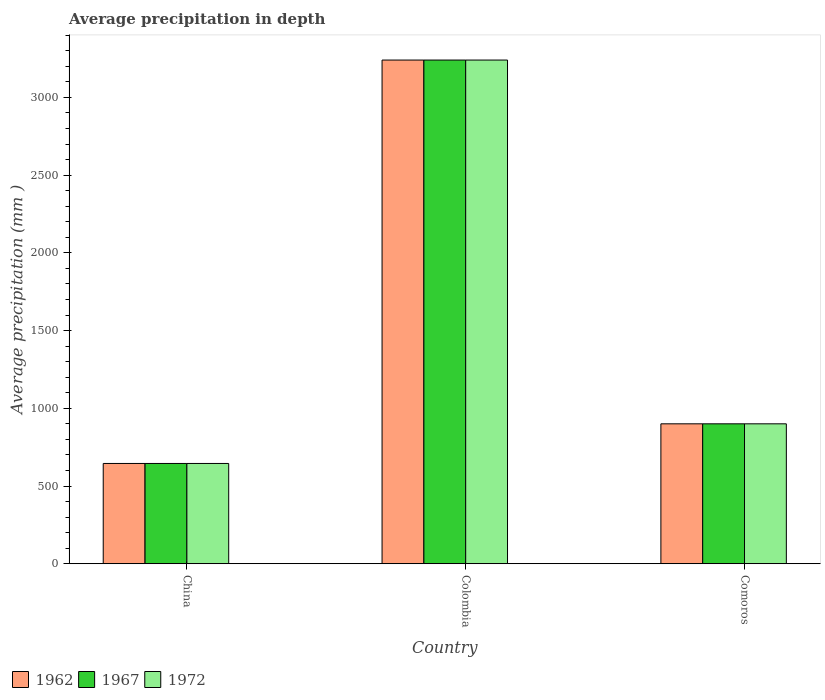How many different coloured bars are there?
Keep it short and to the point. 3. Are the number of bars per tick equal to the number of legend labels?
Your response must be concise. Yes. How many bars are there on the 1st tick from the left?
Provide a succinct answer. 3. What is the label of the 2nd group of bars from the left?
Offer a very short reply. Colombia. In how many cases, is the number of bars for a given country not equal to the number of legend labels?
Keep it short and to the point. 0. What is the average precipitation in 1972 in Comoros?
Offer a very short reply. 900. Across all countries, what is the maximum average precipitation in 1972?
Provide a short and direct response. 3240. Across all countries, what is the minimum average precipitation in 1972?
Keep it short and to the point. 645. In which country was the average precipitation in 1972 maximum?
Keep it short and to the point. Colombia. What is the total average precipitation in 1962 in the graph?
Keep it short and to the point. 4785. What is the difference between the average precipitation in 1962 in Colombia and that in Comoros?
Offer a terse response. 2340. What is the difference between the average precipitation in 1967 in Colombia and the average precipitation in 1962 in Comoros?
Provide a succinct answer. 2340. What is the average average precipitation in 1972 per country?
Give a very brief answer. 1595. In how many countries, is the average precipitation in 1972 greater than 600 mm?
Your answer should be compact. 3. What is the ratio of the average precipitation in 1972 in Colombia to that in Comoros?
Provide a succinct answer. 3.6. Is the average precipitation in 1972 in Colombia less than that in Comoros?
Your answer should be very brief. No. Is the difference between the average precipitation in 1972 in China and Comoros greater than the difference between the average precipitation in 1967 in China and Comoros?
Make the answer very short. No. What is the difference between the highest and the second highest average precipitation in 1972?
Keep it short and to the point. 2340. What is the difference between the highest and the lowest average precipitation in 1972?
Give a very brief answer. 2595. In how many countries, is the average precipitation in 1967 greater than the average average precipitation in 1967 taken over all countries?
Keep it short and to the point. 1. Is it the case that in every country, the sum of the average precipitation in 1967 and average precipitation in 1972 is greater than the average precipitation in 1962?
Provide a short and direct response. Yes. How many bars are there?
Your answer should be compact. 9. Are all the bars in the graph horizontal?
Your response must be concise. No. How many countries are there in the graph?
Give a very brief answer. 3. What is the difference between two consecutive major ticks on the Y-axis?
Offer a very short reply. 500. Does the graph contain grids?
Provide a short and direct response. No. Where does the legend appear in the graph?
Make the answer very short. Bottom left. How many legend labels are there?
Make the answer very short. 3. What is the title of the graph?
Ensure brevity in your answer.  Average precipitation in depth. Does "1972" appear as one of the legend labels in the graph?
Provide a short and direct response. Yes. What is the label or title of the X-axis?
Keep it short and to the point. Country. What is the label or title of the Y-axis?
Your response must be concise. Average precipitation (mm ). What is the Average precipitation (mm ) in 1962 in China?
Offer a terse response. 645. What is the Average precipitation (mm ) of 1967 in China?
Provide a short and direct response. 645. What is the Average precipitation (mm ) of 1972 in China?
Your response must be concise. 645. What is the Average precipitation (mm ) in 1962 in Colombia?
Your response must be concise. 3240. What is the Average precipitation (mm ) of 1967 in Colombia?
Offer a very short reply. 3240. What is the Average precipitation (mm ) of 1972 in Colombia?
Provide a succinct answer. 3240. What is the Average precipitation (mm ) of 1962 in Comoros?
Provide a short and direct response. 900. What is the Average precipitation (mm ) in 1967 in Comoros?
Ensure brevity in your answer.  900. What is the Average precipitation (mm ) in 1972 in Comoros?
Offer a very short reply. 900. Across all countries, what is the maximum Average precipitation (mm ) in 1962?
Give a very brief answer. 3240. Across all countries, what is the maximum Average precipitation (mm ) of 1967?
Make the answer very short. 3240. Across all countries, what is the maximum Average precipitation (mm ) in 1972?
Keep it short and to the point. 3240. Across all countries, what is the minimum Average precipitation (mm ) of 1962?
Offer a terse response. 645. Across all countries, what is the minimum Average precipitation (mm ) of 1967?
Ensure brevity in your answer.  645. Across all countries, what is the minimum Average precipitation (mm ) of 1972?
Provide a short and direct response. 645. What is the total Average precipitation (mm ) in 1962 in the graph?
Keep it short and to the point. 4785. What is the total Average precipitation (mm ) in 1967 in the graph?
Provide a short and direct response. 4785. What is the total Average precipitation (mm ) in 1972 in the graph?
Make the answer very short. 4785. What is the difference between the Average precipitation (mm ) of 1962 in China and that in Colombia?
Offer a very short reply. -2595. What is the difference between the Average precipitation (mm ) of 1967 in China and that in Colombia?
Provide a short and direct response. -2595. What is the difference between the Average precipitation (mm ) of 1972 in China and that in Colombia?
Give a very brief answer. -2595. What is the difference between the Average precipitation (mm ) in 1962 in China and that in Comoros?
Ensure brevity in your answer.  -255. What is the difference between the Average precipitation (mm ) of 1967 in China and that in Comoros?
Offer a terse response. -255. What is the difference between the Average precipitation (mm ) of 1972 in China and that in Comoros?
Ensure brevity in your answer.  -255. What is the difference between the Average precipitation (mm ) of 1962 in Colombia and that in Comoros?
Provide a short and direct response. 2340. What is the difference between the Average precipitation (mm ) in 1967 in Colombia and that in Comoros?
Your response must be concise. 2340. What is the difference between the Average precipitation (mm ) in 1972 in Colombia and that in Comoros?
Offer a terse response. 2340. What is the difference between the Average precipitation (mm ) in 1962 in China and the Average precipitation (mm ) in 1967 in Colombia?
Offer a very short reply. -2595. What is the difference between the Average precipitation (mm ) of 1962 in China and the Average precipitation (mm ) of 1972 in Colombia?
Your answer should be compact. -2595. What is the difference between the Average precipitation (mm ) in 1967 in China and the Average precipitation (mm ) in 1972 in Colombia?
Keep it short and to the point. -2595. What is the difference between the Average precipitation (mm ) of 1962 in China and the Average precipitation (mm ) of 1967 in Comoros?
Keep it short and to the point. -255. What is the difference between the Average precipitation (mm ) of 1962 in China and the Average precipitation (mm ) of 1972 in Comoros?
Offer a very short reply. -255. What is the difference between the Average precipitation (mm ) of 1967 in China and the Average precipitation (mm ) of 1972 in Comoros?
Offer a very short reply. -255. What is the difference between the Average precipitation (mm ) in 1962 in Colombia and the Average precipitation (mm ) in 1967 in Comoros?
Your response must be concise. 2340. What is the difference between the Average precipitation (mm ) of 1962 in Colombia and the Average precipitation (mm ) of 1972 in Comoros?
Ensure brevity in your answer.  2340. What is the difference between the Average precipitation (mm ) of 1967 in Colombia and the Average precipitation (mm ) of 1972 in Comoros?
Give a very brief answer. 2340. What is the average Average precipitation (mm ) in 1962 per country?
Your answer should be very brief. 1595. What is the average Average precipitation (mm ) in 1967 per country?
Offer a very short reply. 1595. What is the average Average precipitation (mm ) in 1972 per country?
Keep it short and to the point. 1595. What is the difference between the Average precipitation (mm ) of 1962 and Average precipitation (mm ) of 1967 in China?
Your response must be concise. 0. What is the difference between the Average precipitation (mm ) in 1962 and Average precipitation (mm ) in 1972 in China?
Make the answer very short. 0. What is the difference between the Average precipitation (mm ) of 1967 and Average precipitation (mm ) of 1972 in China?
Provide a succinct answer. 0. What is the difference between the Average precipitation (mm ) of 1967 and Average precipitation (mm ) of 1972 in Colombia?
Make the answer very short. 0. What is the difference between the Average precipitation (mm ) of 1967 and Average precipitation (mm ) of 1972 in Comoros?
Offer a very short reply. 0. What is the ratio of the Average precipitation (mm ) of 1962 in China to that in Colombia?
Offer a very short reply. 0.2. What is the ratio of the Average precipitation (mm ) in 1967 in China to that in Colombia?
Provide a succinct answer. 0.2. What is the ratio of the Average precipitation (mm ) of 1972 in China to that in Colombia?
Your response must be concise. 0.2. What is the ratio of the Average precipitation (mm ) in 1962 in China to that in Comoros?
Provide a short and direct response. 0.72. What is the ratio of the Average precipitation (mm ) in 1967 in China to that in Comoros?
Your answer should be compact. 0.72. What is the ratio of the Average precipitation (mm ) of 1972 in China to that in Comoros?
Offer a very short reply. 0.72. What is the ratio of the Average precipitation (mm ) of 1962 in Colombia to that in Comoros?
Provide a short and direct response. 3.6. What is the ratio of the Average precipitation (mm ) of 1967 in Colombia to that in Comoros?
Your response must be concise. 3.6. What is the ratio of the Average precipitation (mm ) in 1972 in Colombia to that in Comoros?
Provide a short and direct response. 3.6. What is the difference between the highest and the second highest Average precipitation (mm ) in 1962?
Your answer should be very brief. 2340. What is the difference between the highest and the second highest Average precipitation (mm ) in 1967?
Provide a succinct answer. 2340. What is the difference between the highest and the second highest Average precipitation (mm ) of 1972?
Ensure brevity in your answer.  2340. What is the difference between the highest and the lowest Average precipitation (mm ) in 1962?
Keep it short and to the point. 2595. What is the difference between the highest and the lowest Average precipitation (mm ) in 1967?
Offer a terse response. 2595. What is the difference between the highest and the lowest Average precipitation (mm ) of 1972?
Ensure brevity in your answer.  2595. 